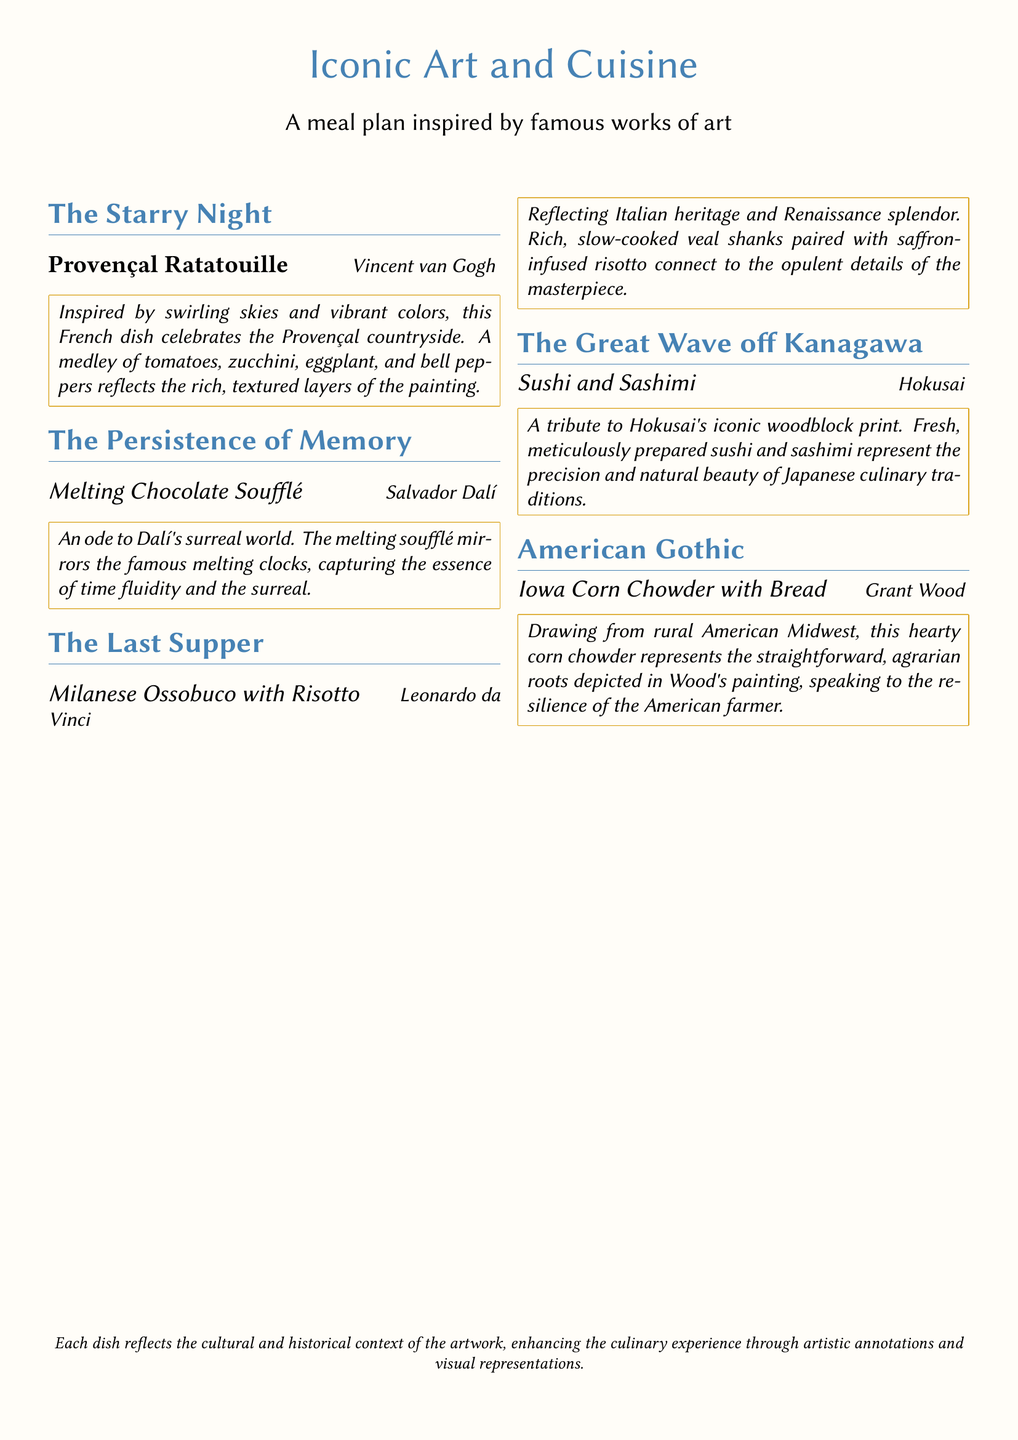What is the title of the meal inspired by Vincent van Gogh? The title of the meal is directly mentioned under the artwork inspired by Vincent van Gogh, which is "Provençal Ratatouille."
Answer: Provençal Ratatouille Who created the artwork "The Great Wave off Kanagawa"? The creator of the artwork "The Great Wave off Kanagawa" is stated in the document as Hokusai.
Answer: Hokusai What is the main ingredient in the Milanese Ossobuco? The main ingredient for the dish "Milanese Ossobuco with Risotto" as described is rich, slow-cooked veal shanks.
Answer: Veal shanks Which dish reflects the cultural background of rural American Midwest? The specific dish that reflects this cultural background is stated as "Iowa Corn Chowder with Bread."
Answer: Iowa Corn Chowder with Bread What is the color scheme inspired by in the Provençal Ratatouille? The color scheme of the Provençal Ratatouille is inspired by the swirling skies and vibrant colors seen in the painting.
Answer: Swirling skies and vibrant colors How many sections are there in the meal plan? The document provides five distinct sections, each focused on a different piece of art and its corresponding dish.
Answer: Five 